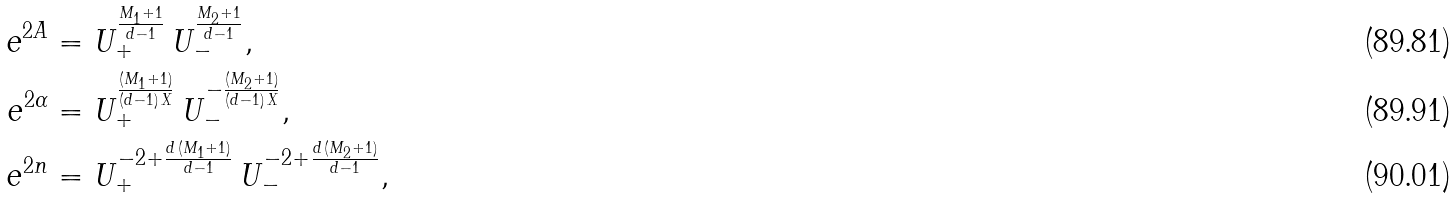<formula> <loc_0><loc_0><loc_500><loc_500>e ^ { 2 A } & = U _ { + } ^ { \frac { M _ { 1 } + 1 } { d - 1 } } \, U _ { - } ^ { \frac { M _ { 2 } + 1 } { d - 1 } } , \\ e ^ { 2 \alpha } & = U _ { + } ^ { \frac { ( M _ { 1 } + 1 ) } { ( d - 1 ) \, X } } \, U _ { - } ^ { - \frac { ( M _ { 2 } + 1 ) } { ( d - 1 ) \, X } } , \\ e ^ { 2 n } & = U _ { + } ^ { - 2 + \frac { d \, ( M _ { 1 } + 1 ) } { d - 1 } } \, U _ { - } ^ { - 2 + \frac { d \, ( M _ { 2 } + 1 ) } { d - 1 } } ,</formula> 